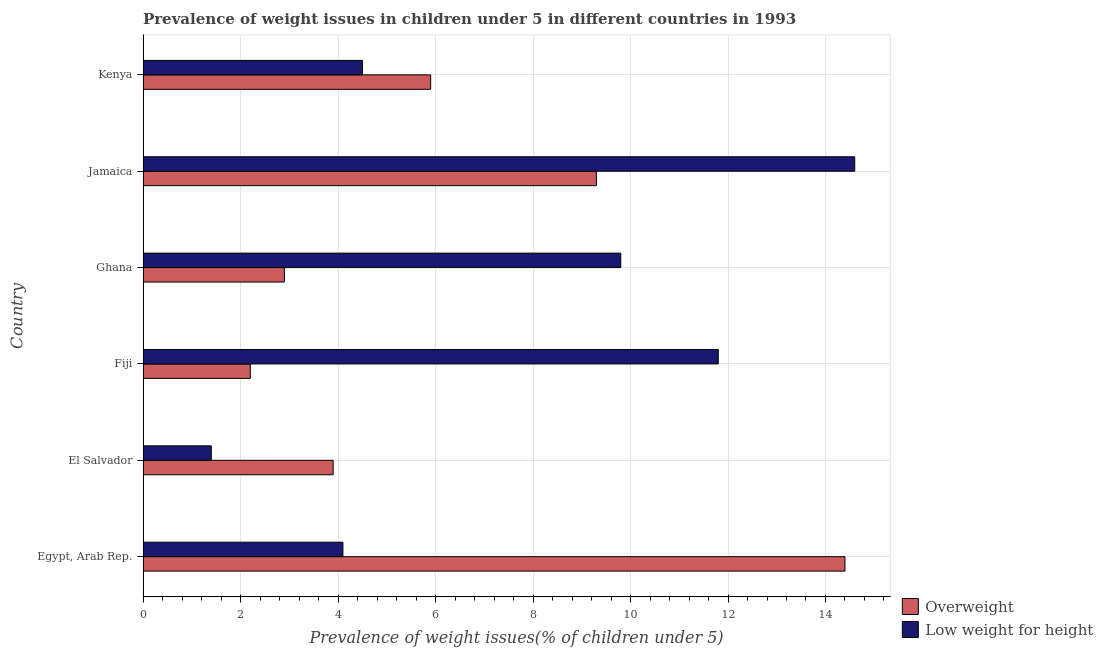How many different coloured bars are there?
Provide a succinct answer. 2. Are the number of bars on each tick of the Y-axis equal?
Your response must be concise. Yes. How many bars are there on the 2nd tick from the top?
Offer a terse response. 2. What is the label of the 3rd group of bars from the top?
Keep it short and to the point. Ghana. Across all countries, what is the maximum percentage of overweight children?
Give a very brief answer. 14.4. Across all countries, what is the minimum percentage of underweight children?
Your response must be concise. 1.4. In which country was the percentage of overweight children maximum?
Make the answer very short. Egypt, Arab Rep. In which country was the percentage of underweight children minimum?
Offer a very short reply. El Salvador. What is the total percentage of overweight children in the graph?
Keep it short and to the point. 38.6. What is the difference between the percentage of underweight children in Egypt, Arab Rep. and that in Fiji?
Give a very brief answer. -7.7. What is the difference between the percentage of underweight children in Fiji and the percentage of overweight children in Egypt, Arab Rep.?
Offer a terse response. -2.6. What is the average percentage of overweight children per country?
Provide a short and direct response. 6.43. What is the difference between the percentage of underweight children and percentage of overweight children in Egypt, Arab Rep.?
Provide a succinct answer. -10.3. In how many countries, is the percentage of overweight children greater than 9.2 %?
Ensure brevity in your answer.  2. What is the ratio of the percentage of overweight children in Fiji to that in Jamaica?
Your response must be concise. 0.24. Is the difference between the percentage of underweight children in Egypt, Arab Rep. and Fiji greater than the difference between the percentage of overweight children in Egypt, Arab Rep. and Fiji?
Ensure brevity in your answer.  No. What is the difference between the highest and the second highest percentage of underweight children?
Offer a terse response. 2.8. In how many countries, is the percentage of underweight children greater than the average percentage of underweight children taken over all countries?
Make the answer very short. 3. Is the sum of the percentage of overweight children in Egypt, Arab Rep. and Ghana greater than the maximum percentage of underweight children across all countries?
Offer a very short reply. Yes. What does the 2nd bar from the top in El Salvador represents?
Keep it short and to the point. Overweight. What does the 1st bar from the bottom in Egypt, Arab Rep. represents?
Your response must be concise. Overweight. How many bars are there?
Ensure brevity in your answer.  12. How many countries are there in the graph?
Provide a short and direct response. 6. Are the values on the major ticks of X-axis written in scientific E-notation?
Offer a terse response. No. Does the graph contain any zero values?
Provide a succinct answer. No. What is the title of the graph?
Your answer should be compact. Prevalence of weight issues in children under 5 in different countries in 1993. Does "Under-5(female)" appear as one of the legend labels in the graph?
Give a very brief answer. No. What is the label or title of the X-axis?
Offer a terse response. Prevalence of weight issues(% of children under 5). What is the label or title of the Y-axis?
Offer a terse response. Country. What is the Prevalence of weight issues(% of children under 5) in Overweight in Egypt, Arab Rep.?
Keep it short and to the point. 14.4. What is the Prevalence of weight issues(% of children under 5) of Low weight for height in Egypt, Arab Rep.?
Keep it short and to the point. 4.1. What is the Prevalence of weight issues(% of children under 5) of Overweight in El Salvador?
Your answer should be compact. 3.9. What is the Prevalence of weight issues(% of children under 5) of Low weight for height in El Salvador?
Your response must be concise. 1.4. What is the Prevalence of weight issues(% of children under 5) of Overweight in Fiji?
Give a very brief answer. 2.2. What is the Prevalence of weight issues(% of children under 5) in Low weight for height in Fiji?
Offer a very short reply. 11.8. What is the Prevalence of weight issues(% of children under 5) of Overweight in Ghana?
Your response must be concise. 2.9. What is the Prevalence of weight issues(% of children under 5) in Low weight for height in Ghana?
Your answer should be very brief. 9.8. What is the Prevalence of weight issues(% of children under 5) of Overweight in Jamaica?
Ensure brevity in your answer.  9.3. What is the Prevalence of weight issues(% of children under 5) of Low weight for height in Jamaica?
Your answer should be very brief. 14.6. What is the Prevalence of weight issues(% of children under 5) in Overweight in Kenya?
Make the answer very short. 5.9. What is the Prevalence of weight issues(% of children under 5) of Low weight for height in Kenya?
Provide a short and direct response. 4.5. Across all countries, what is the maximum Prevalence of weight issues(% of children under 5) in Overweight?
Your answer should be very brief. 14.4. Across all countries, what is the maximum Prevalence of weight issues(% of children under 5) of Low weight for height?
Offer a terse response. 14.6. Across all countries, what is the minimum Prevalence of weight issues(% of children under 5) in Overweight?
Provide a short and direct response. 2.2. Across all countries, what is the minimum Prevalence of weight issues(% of children under 5) of Low weight for height?
Make the answer very short. 1.4. What is the total Prevalence of weight issues(% of children under 5) of Overweight in the graph?
Provide a succinct answer. 38.6. What is the total Prevalence of weight issues(% of children under 5) in Low weight for height in the graph?
Provide a succinct answer. 46.2. What is the difference between the Prevalence of weight issues(% of children under 5) of Overweight in Egypt, Arab Rep. and that in El Salvador?
Make the answer very short. 10.5. What is the difference between the Prevalence of weight issues(% of children under 5) of Overweight in Egypt, Arab Rep. and that in Fiji?
Make the answer very short. 12.2. What is the difference between the Prevalence of weight issues(% of children under 5) in Overweight in Egypt, Arab Rep. and that in Ghana?
Give a very brief answer. 11.5. What is the difference between the Prevalence of weight issues(% of children under 5) of Low weight for height in Egypt, Arab Rep. and that in Ghana?
Your response must be concise. -5.7. What is the difference between the Prevalence of weight issues(% of children under 5) of Low weight for height in Egypt, Arab Rep. and that in Jamaica?
Provide a short and direct response. -10.5. What is the difference between the Prevalence of weight issues(% of children under 5) of Overweight in Egypt, Arab Rep. and that in Kenya?
Your answer should be very brief. 8.5. What is the difference between the Prevalence of weight issues(% of children under 5) of Low weight for height in Egypt, Arab Rep. and that in Kenya?
Offer a very short reply. -0.4. What is the difference between the Prevalence of weight issues(% of children under 5) in Overweight in El Salvador and that in Fiji?
Provide a succinct answer. 1.7. What is the difference between the Prevalence of weight issues(% of children under 5) of Low weight for height in El Salvador and that in Ghana?
Your answer should be very brief. -8.4. What is the difference between the Prevalence of weight issues(% of children under 5) in Overweight in El Salvador and that in Jamaica?
Keep it short and to the point. -5.4. What is the difference between the Prevalence of weight issues(% of children under 5) in Low weight for height in El Salvador and that in Jamaica?
Your answer should be very brief. -13.2. What is the difference between the Prevalence of weight issues(% of children under 5) in Overweight in El Salvador and that in Kenya?
Your answer should be compact. -2. What is the difference between the Prevalence of weight issues(% of children under 5) of Overweight in Fiji and that in Ghana?
Keep it short and to the point. -0.7. What is the difference between the Prevalence of weight issues(% of children under 5) of Low weight for height in Fiji and that in Ghana?
Your answer should be very brief. 2. What is the difference between the Prevalence of weight issues(% of children under 5) in Overweight in Fiji and that in Jamaica?
Make the answer very short. -7.1. What is the difference between the Prevalence of weight issues(% of children under 5) in Overweight in Fiji and that in Kenya?
Provide a succinct answer. -3.7. What is the difference between the Prevalence of weight issues(% of children under 5) in Low weight for height in Fiji and that in Kenya?
Offer a terse response. 7.3. What is the difference between the Prevalence of weight issues(% of children under 5) of Low weight for height in Ghana and that in Kenya?
Provide a short and direct response. 5.3. What is the difference between the Prevalence of weight issues(% of children under 5) in Overweight in Jamaica and that in Kenya?
Offer a terse response. 3.4. What is the difference between the Prevalence of weight issues(% of children under 5) in Low weight for height in Jamaica and that in Kenya?
Provide a short and direct response. 10.1. What is the difference between the Prevalence of weight issues(% of children under 5) of Overweight in Egypt, Arab Rep. and the Prevalence of weight issues(% of children under 5) of Low weight for height in El Salvador?
Your answer should be compact. 13. What is the difference between the Prevalence of weight issues(% of children under 5) of Overweight in Egypt, Arab Rep. and the Prevalence of weight issues(% of children under 5) of Low weight for height in Ghana?
Give a very brief answer. 4.6. What is the difference between the Prevalence of weight issues(% of children under 5) in Overweight in El Salvador and the Prevalence of weight issues(% of children under 5) in Low weight for height in Ghana?
Your answer should be compact. -5.9. What is the difference between the Prevalence of weight issues(% of children under 5) of Overweight in El Salvador and the Prevalence of weight issues(% of children under 5) of Low weight for height in Jamaica?
Your answer should be compact. -10.7. What is the difference between the Prevalence of weight issues(% of children under 5) of Overweight in El Salvador and the Prevalence of weight issues(% of children under 5) of Low weight for height in Kenya?
Your answer should be compact. -0.6. What is the difference between the Prevalence of weight issues(% of children under 5) of Overweight in Ghana and the Prevalence of weight issues(% of children under 5) of Low weight for height in Jamaica?
Your answer should be very brief. -11.7. What is the average Prevalence of weight issues(% of children under 5) of Overweight per country?
Keep it short and to the point. 6.43. What is the average Prevalence of weight issues(% of children under 5) in Low weight for height per country?
Offer a terse response. 7.7. What is the difference between the Prevalence of weight issues(% of children under 5) in Overweight and Prevalence of weight issues(% of children under 5) in Low weight for height in Egypt, Arab Rep.?
Provide a short and direct response. 10.3. What is the difference between the Prevalence of weight issues(% of children under 5) in Overweight and Prevalence of weight issues(% of children under 5) in Low weight for height in El Salvador?
Provide a succinct answer. 2.5. What is the difference between the Prevalence of weight issues(% of children under 5) of Overweight and Prevalence of weight issues(% of children under 5) of Low weight for height in Jamaica?
Offer a terse response. -5.3. What is the ratio of the Prevalence of weight issues(% of children under 5) in Overweight in Egypt, Arab Rep. to that in El Salvador?
Your answer should be very brief. 3.69. What is the ratio of the Prevalence of weight issues(% of children under 5) of Low weight for height in Egypt, Arab Rep. to that in El Salvador?
Make the answer very short. 2.93. What is the ratio of the Prevalence of weight issues(% of children under 5) of Overweight in Egypt, Arab Rep. to that in Fiji?
Your answer should be very brief. 6.55. What is the ratio of the Prevalence of weight issues(% of children under 5) of Low weight for height in Egypt, Arab Rep. to that in Fiji?
Your response must be concise. 0.35. What is the ratio of the Prevalence of weight issues(% of children under 5) in Overweight in Egypt, Arab Rep. to that in Ghana?
Your response must be concise. 4.97. What is the ratio of the Prevalence of weight issues(% of children under 5) in Low weight for height in Egypt, Arab Rep. to that in Ghana?
Give a very brief answer. 0.42. What is the ratio of the Prevalence of weight issues(% of children under 5) in Overweight in Egypt, Arab Rep. to that in Jamaica?
Provide a short and direct response. 1.55. What is the ratio of the Prevalence of weight issues(% of children under 5) of Low weight for height in Egypt, Arab Rep. to that in Jamaica?
Offer a very short reply. 0.28. What is the ratio of the Prevalence of weight issues(% of children under 5) of Overweight in Egypt, Arab Rep. to that in Kenya?
Offer a terse response. 2.44. What is the ratio of the Prevalence of weight issues(% of children under 5) in Low weight for height in Egypt, Arab Rep. to that in Kenya?
Make the answer very short. 0.91. What is the ratio of the Prevalence of weight issues(% of children under 5) in Overweight in El Salvador to that in Fiji?
Make the answer very short. 1.77. What is the ratio of the Prevalence of weight issues(% of children under 5) of Low weight for height in El Salvador to that in Fiji?
Offer a very short reply. 0.12. What is the ratio of the Prevalence of weight issues(% of children under 5) in Overweight in El Salvador to that in Ghana?
Provide a short and direct response. 1.34. What is the ratio of the Prevalence of weight issues(% of children under 5) of Low weight for height in El Salvador to that in Ghana?
Your response must be concise. 0.14. What is the ratio of the Prevalence of weight issues(% of children under 5) of Overweight in El Salvador to that in Jamaica?
Ensure brevity in your answer.  0.42. What is the ratio of the Prevalence of weight issues(% of children under 5) in Low weight for height in El Salvador to that in Jamaica?
Provide a succinct answer. 0.1. What is the ratio of the Prevalence of weight issues(% of children under 5) in Overweight in El Salvador to that in Kenya?
Your answer should be very brief. 0.66. What is the ratio of the Prevalence of weight issues(% of children under 5) in Low weight for height in El Salvador to that in Kenya?
Provide a succinct answer. 0.31. What is the ratio of the Prevalence of weight issues(% of children under 5) of Overweight in Fiji to that in Ghana?
Offer a very short reply. 0.76. What is the ratio of the Prevalence of weight issues(% of children under 5) of Low weight for height in Fiji to that in Ghana?
Offer a very short reply. 1.2. What is the ratio of the Prevalence of weight issues(% of children under 5) of Overweight in Fiji to that in Jamaica?
Provide a short and direct response. 0.24. What is the ratio of the Prevalence of weight issues(% of children under 5) of Low weight for height in Fiji to that in Jamaica?
Ensure brevity in your answer.  0.81. What is the ratio of the Prevalence of weight issues(% of children under 5) in Overweight in Fiji to that in Kenya?
Provide a succinct answer. 0.37. What is the ratio of the Prevalence of weight issues(% of children under 5) in Low weight for height in Fiji to that in Kenya?
Your answer should be compact. 2.62. What is the ratio of the Prevalence of weight issues(% of children under 5) in Overweight in Ghana to that in Jamaica?
Ensure brevity in your answer.  0.31. What is the ratio of the Prevalence of weight issues(% of children under 5) in Low weight for height in Ghana to that in Jamaica?
Keep it short and to the point. 0.67. What is the ratio of the Prevalence of weight issues(% of children under 5) of Overweight in Ghana to that in Kenya?
Provide a short and direct response. 0.49. What is the ratio of the Prevalence of weight issues(% of children under 5) in Low weight for height in Ghana to that in Kenya?
Ensure brevity in your answer.  2.18. What is the ratio of the Prevalence of weight issues(% of children under 5) in Overweight in Jamaica to that in Kenya?
Give a very brief answer. 1.58. What is the ratio of the Prevalence of weight issues(% of children under 5) in Low weight for height in Jamaica to that in Kenya?
Your answer should be compact. 3.24. What is the difference between the highest and the second highest Prevalence of weight issues(% of children under 5) in Overweight?
Offer a very short reply. 5.1. What is the difference between the highest and the lowest Prevalence of weight issues(% of children under 5) in Overweight?
Your answer should be very brief. 12.2. What is the difference between the highest and the lowest Prevalence of weight issues(% of children under 5) of Low weight for height?
Give a very brief answer. 13.2. 